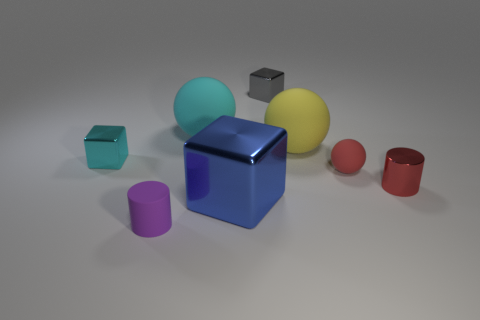There is a tiny object that is the same color as the tiny sphere; what shape is it?
Offer a terse response. Cylinder. What number of objects are either cyan things that are to the right of the tiny purple object or things behind the large blue metal thing?
Offer a terse response. 6. There is a gray thing that is made of the same material as the small red cylinder; what is its size?
Your answer should be compact. Small. Is the shape of the thing on the left side of the purple matte cylinder the same as  the blue metal object?
Ensure brevity in your answer.  Yes. What is the size of the thing that is the same color as the tiny ball?
Make the answer very short. Small. How many cyan objects are either rubber cylinders or small metallic things?
Offer a terse response. 1. What number of other things are the same shape as the small cyan object?
Your answer should be very brief. 2. What shape is the large object that is both right of the large cyan sphere and behind the blue shiny cube?
Offer a terse response. Sphere. There is a cyan ball; are there any tiny purple things on the left side of it?
Give a very brief answer. Yes. What is the size of the red matte thing that is the same shape as the cyan rubber object?
Make the answer very short. Small. 